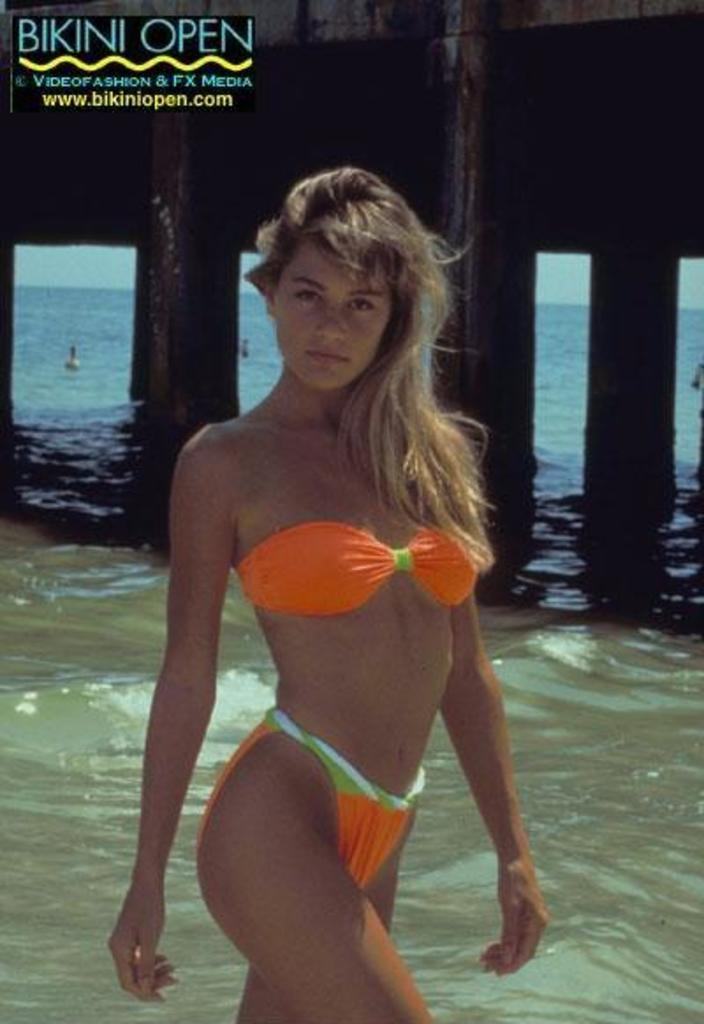Who is the main subject in the image? There is a girl in the image. Where is the girl located in the image? The girl is in the middle of the image. What can be seen in the background of the image? There is water visible in the image. How is the water positioned in relation to the girl? The water is behind the girl. How many legs does the girl have in the image? The number of legs cannot be determined from the image, as it only shows the girl from the front. Is there a hill visible in the image? There is no hill present in the image; it only features a girl and water in the background. 